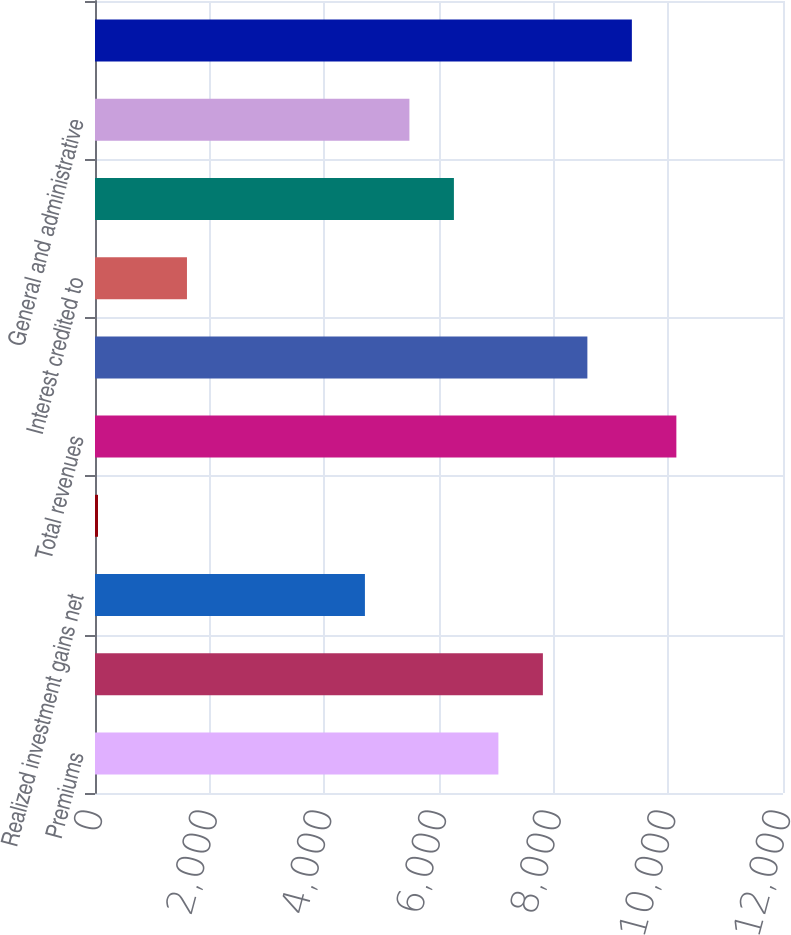Convert chart. <chart><loc_0><loc_0><loc_500><loc_500><bar_chart><fcel>Premiums<fcel>Net investment income<fcel>Realized investment gains net<fcel>Asset management fees and<fcel>Total revenues<fcel>Policyholders' benefits<fcel>Interest credited to<fcel>Dividends to policyholders<fcel>General and administrative<fcel>Total benefits and expenses<nl><fcel>7036<fcel>7812<fcel>4708<fcel>52<fcel>10140<fcel>8588<fcel>1604<fcel>6260<fcel>5484<fcel>9364<nl></chart> 